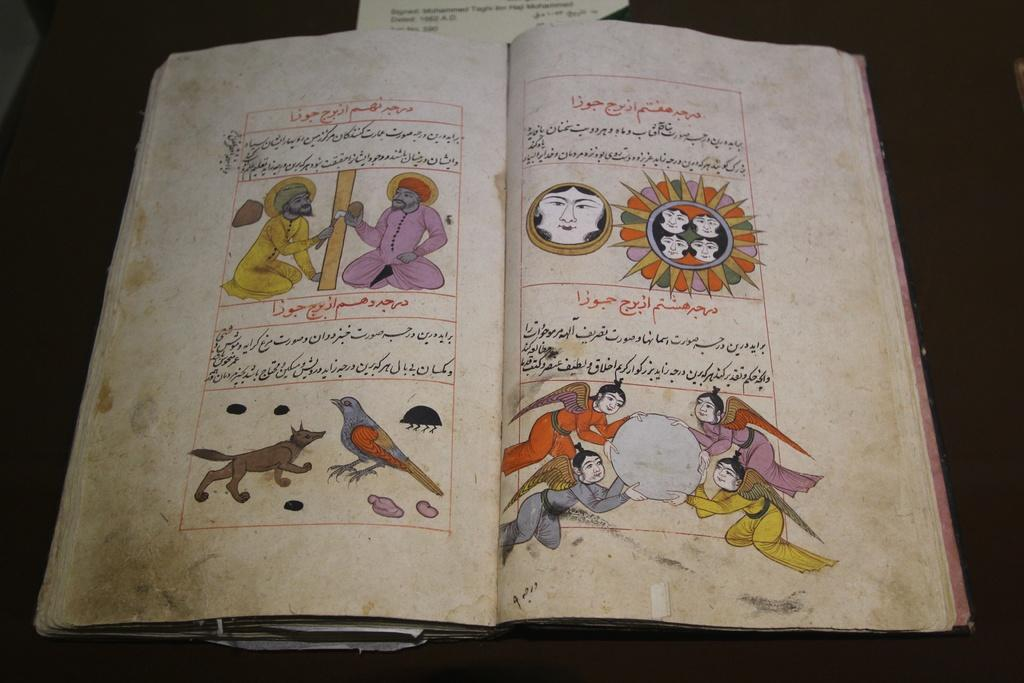What is the main subject of the image? The main subject of the image is an open book. What type of content is depicted in the open book? The open book contains figures of people and animals. What role does the manager play in the history of the rain depicted in the image? There is no mention of a manager, history, or rain in the image; it features an open book with figures of people and animals. 